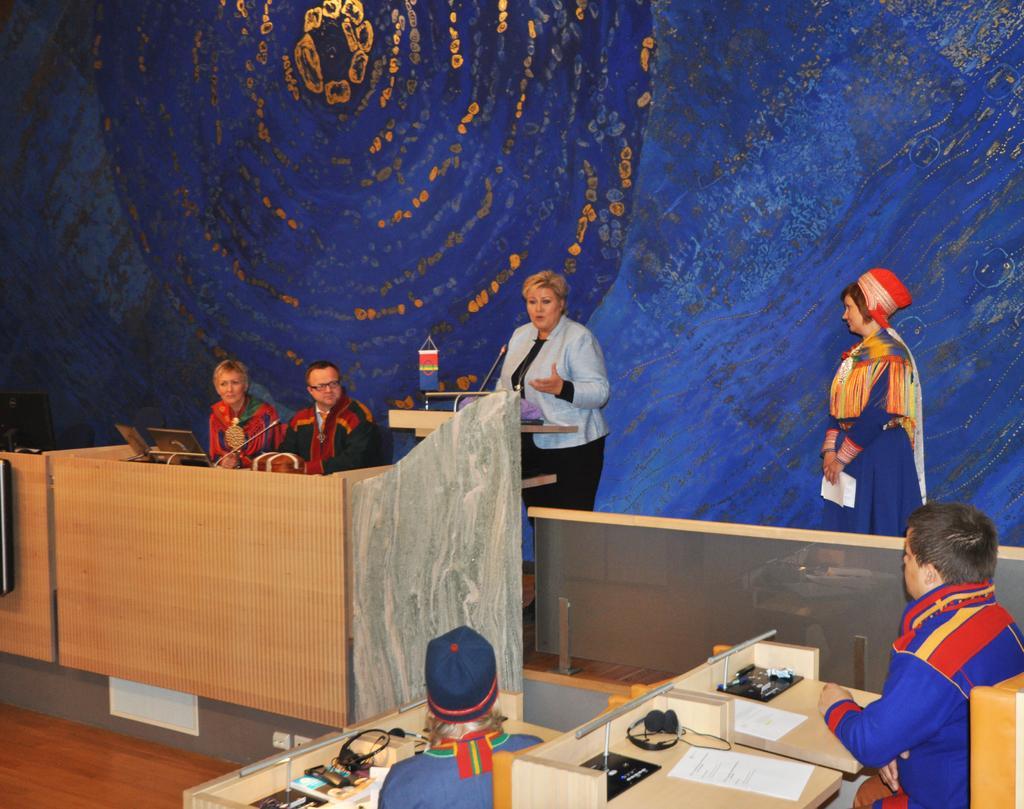Describe this image in one or two sentences. Here we can see few persons and she is talking on the mike. There are tables, papers, headsets, laptops, and mike's. This is floor. There is a blue color background. 